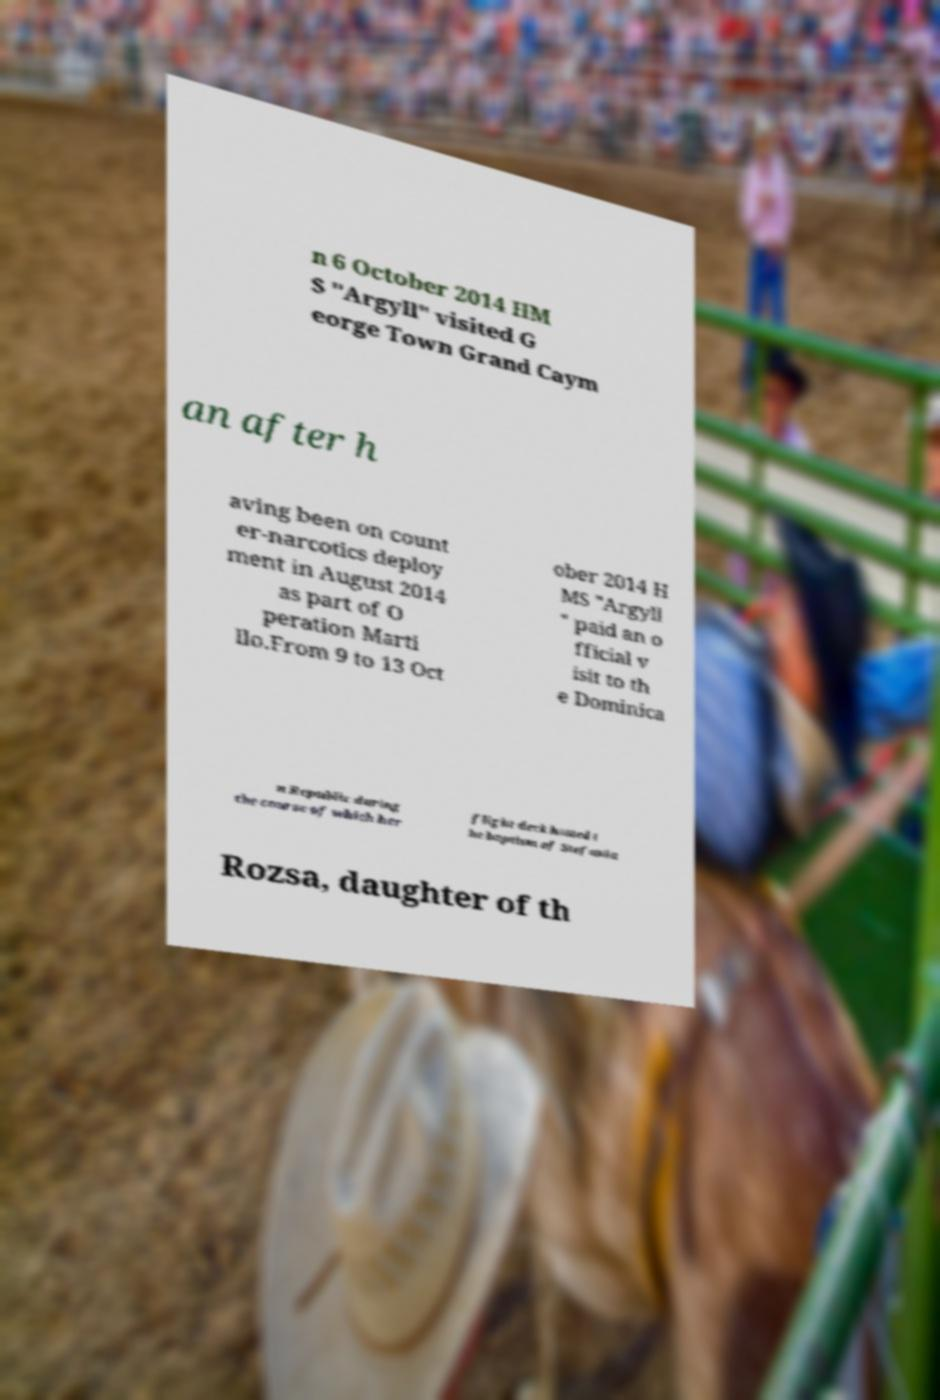Can you accurately transcribe the text from the provided image for me? n 6 October 2014 HM S "Argyll" visited G eorge Town Grand Caym an after h aving been on count er-narcotics deploy ment in August 2014 as part of O peration Marti llo.From 9 to 13 Oct ober 2014 H MS "Argyll " paid an o fficial v isit to th e Dominica n Republic during the course of which her flight deck hosted t he baptism of Stefania Rozsa, daughter of th 